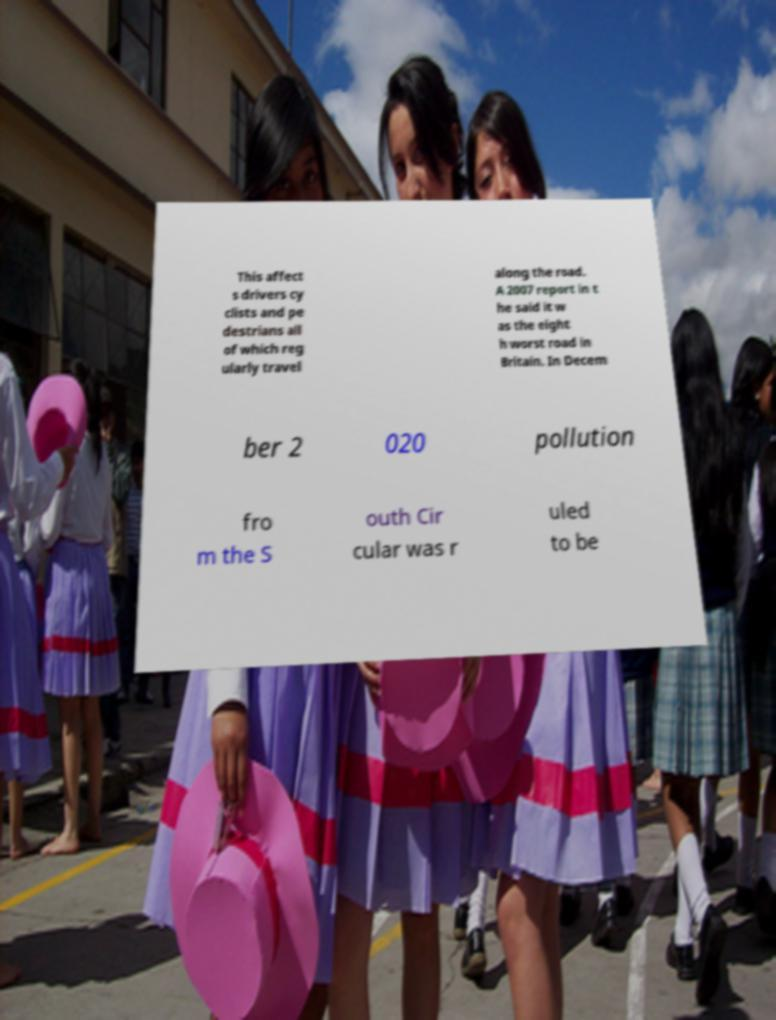Please identify and transcribe the text found in this image. This affect s drivers cy clists and pe destrians all of which reg ularly travel along the road. A 2007 report in t he said it w as the eight h worst road in Britain. In Decem ber 2 020 pollution fro m the S outh Cir cular was r uled to be 